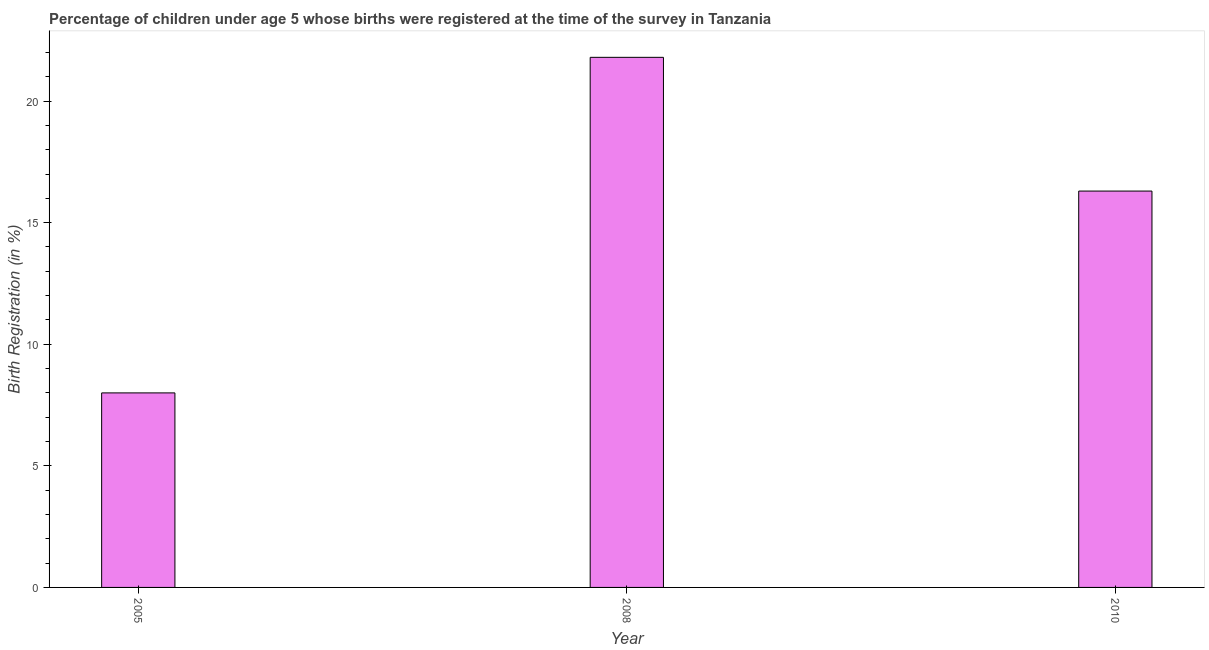Does the graph contain grids?
Provide a short and direct response. No. What is the title of the graph?
Provide a succinct answer. Percentage of children under age 5 whose births were registered at the time of the survey in Tanzania. What is the label or title of the X-axis?
Your answer should be compact. Year. What is the label or title of the Y-axis?
Provide a short and direct response. Birth Registration (in %). What is the birth registration in 2008?
Your answer should be compact. 21.8. Across all years, what is the maximum birth registration?
Provide a succinct answer. 21.8. In which year was the birth registration minimum?
Provide a short and direct response. 2005. What is the sum of the birth registration?
Provide a succinct answer. 46.1. What is the average birth registration per year?
Provide a short and direct response. 15.37. What is the median birth registration?
Offer a very short reply. 16.3. In how many years, is the birth registration greater than 4 %?
Provide a short and direct response. 3. What is the ratio of the birth registration in 2008 to that in 2010?
Offer a terse response. 1.34. Is the birth registration in 2005 less than that in 2008?
Your response must be concise. Yes. What is the difference between the highest and the second highest birth registration?
Your answer should be very brief. 5.5. What is the difference between two consecutive major ticks on the Y-axis?
Ensure brevity in your answer.  5. Are the values on the major ticks of Y-axis written in scientific E-notation?
Ensure brevity in your answer.  No. What is the Birth Registration (in %) of 2008?
Offer a very short reply. 21.8. What is the difference between the Birth Registration (in %) in 2005 and 2008?
Provide a succinct answer. -13.8. What is the difference between the Birth Registration (in %) in 2008 and 2010?
Your answer should be compact. 5.5. What is the ratio of the Birth Registration (in %) in 2005 to that in 2008?
Your answer should be compact. 0.37. What is the ratio of the Birth Registration (in %) in 2005 to that in 2010?
Keep it short and to the point. 0.49. What is the ratio of the Birth Registration (in %) in 2008 to that in 2010?
Your answer should be compact. 1.34. 